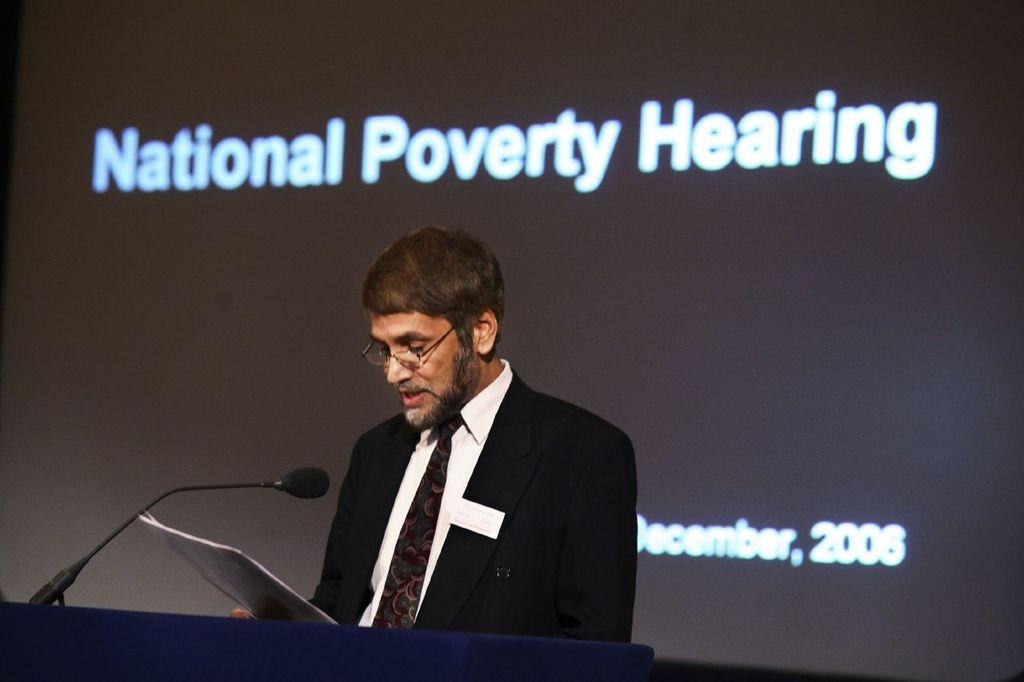What is the person in the image doing? The person is standing in the center of the image and holding a paper. Where is the person standing? The person is standing at a desk. What object is on the desk? There is a microphone on the desk. What can be seen in the background of the image? There is a screen in the background of the image. What type of lace is draped over the microphone in the image? There is no lace present in the image; the microphone is not covered by any fabric. 